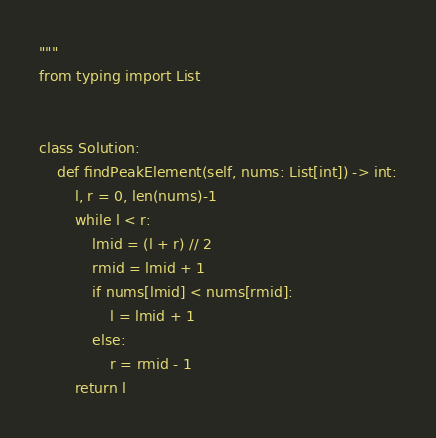Convert code to text. <code><loc_0><loc_0><loc_500><loc_500><_Python_>"""
from typing import List


class Solution:
    def findPeakElement(self, nums: List[int]) -> int:
        l, r = 0, len(nums)-1
        while l < r:
            lmid = (l + r) // 2
            rmid = lmid + 1
            if nums[lmid] < nums[rmid]:
                l = lmid + 1
            else:
                r = rmid - 1
        return l
</code> 